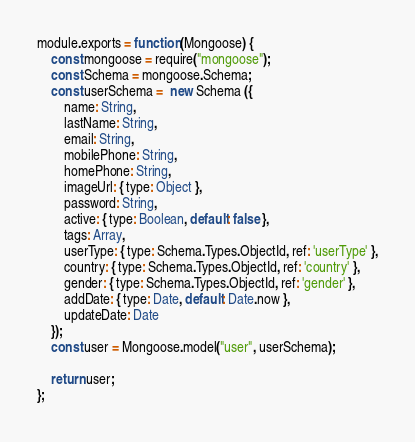<code> <loc_0><loc_0><loc_500><loc_500><_JavaScript_>module.exports = function (Mongoose) {
    const mongoose = require("mongoose");
    const Schema = mongoose.Schema;
    const userSchema =  new Schema ({
        name: String,
        lastName: String,
        email: String,
        mobilePhone: String,
        homePhone: String,
        imageUrl: { type: Object },
        password: String,
        active: { type: Boolean, default: false },
        tags: Array,
        userType: { type: Schema.Types.ObjectId, ref: 'userType' },
        country: { type: Schema.Types.ObjectId, ref: 'country' },
        gender: { type: Schema.Types.ObjectId, ref: 'gender' },
        addDate: { type: Date, default: Date.now },
        updateDate: Date
    });
    const user = Mongoose.model("user", userSchema);

    return user;
};</code> 